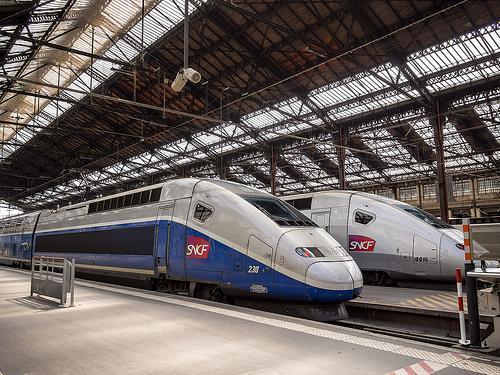How many trains are there?
Give a very brief answer. 2. 